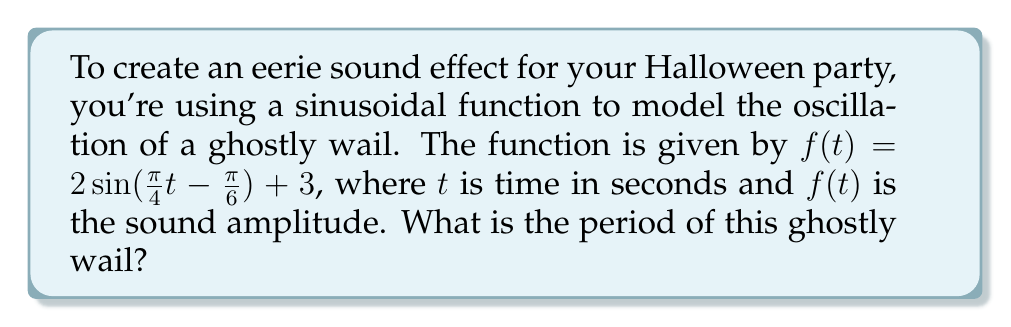Provide a solution to this math problem. To find the period of a sinusoidal function, we need to focus on the argument of the sine function. The general form of a sine function is:

$a\sin(b(t-c)) + d$

where $b$ is related to the period $P$ by the formula:

$b = \frac{2\pi}{P}$

In our function $f(t) = 2\sin(\frac{\pi}{4}t - \frac{\pi}{6}) + 3$, we can identify that $b = \frac{\pi}{4}$.

Now, we can solve for $P$:

$\frac{\pi}{4} = \frac{2\pi}{P}$

Multiply both sides by $P$:

$\frac{\pi}{4}P = 2\pi$

Divide both sides by $\frac{\pi}{4}$:

$P = \frac{2\pi}{\frac{\pi}{4}} = 2\pi \cdot \frac{4}{\pi} = 8$

Therefore, the period of the ghostly wail is 8 seconds.
Answer: 8 seconds 